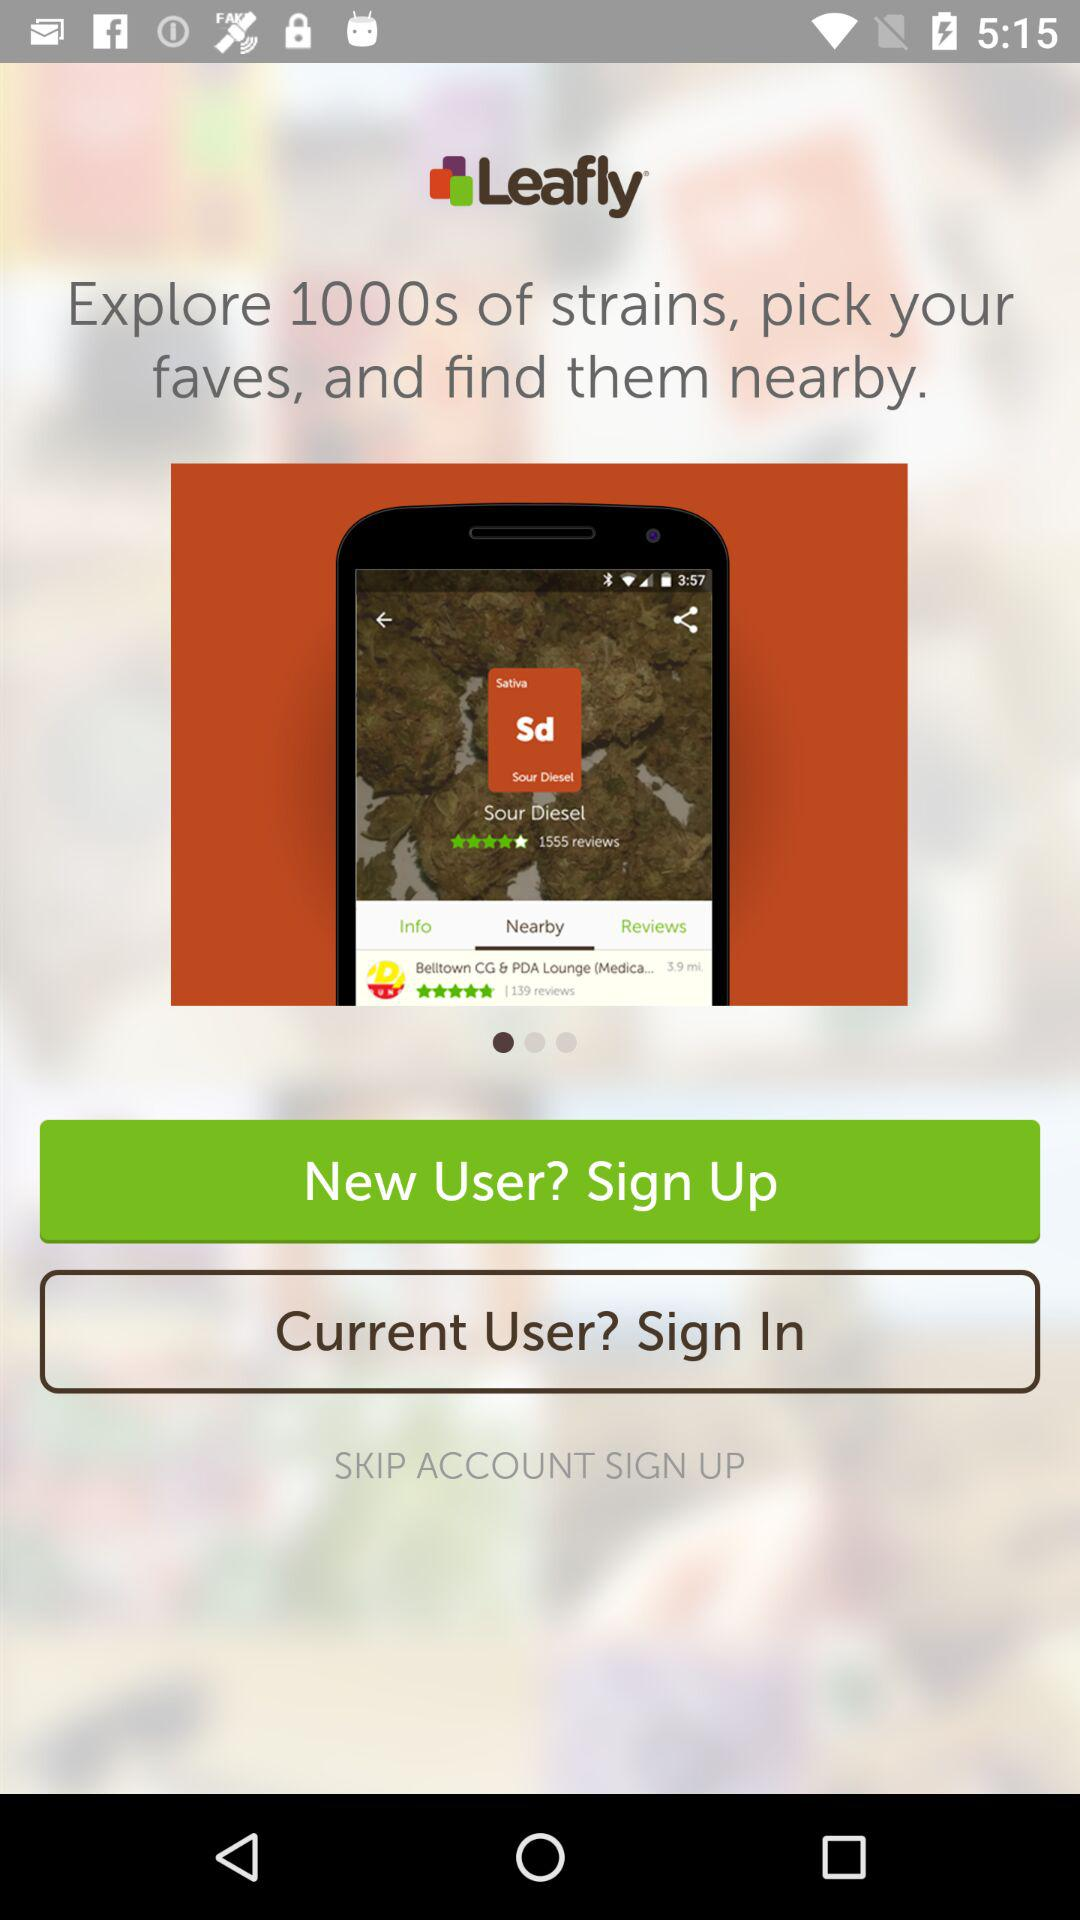What is the name of application? The name of the application is "Leafly". 